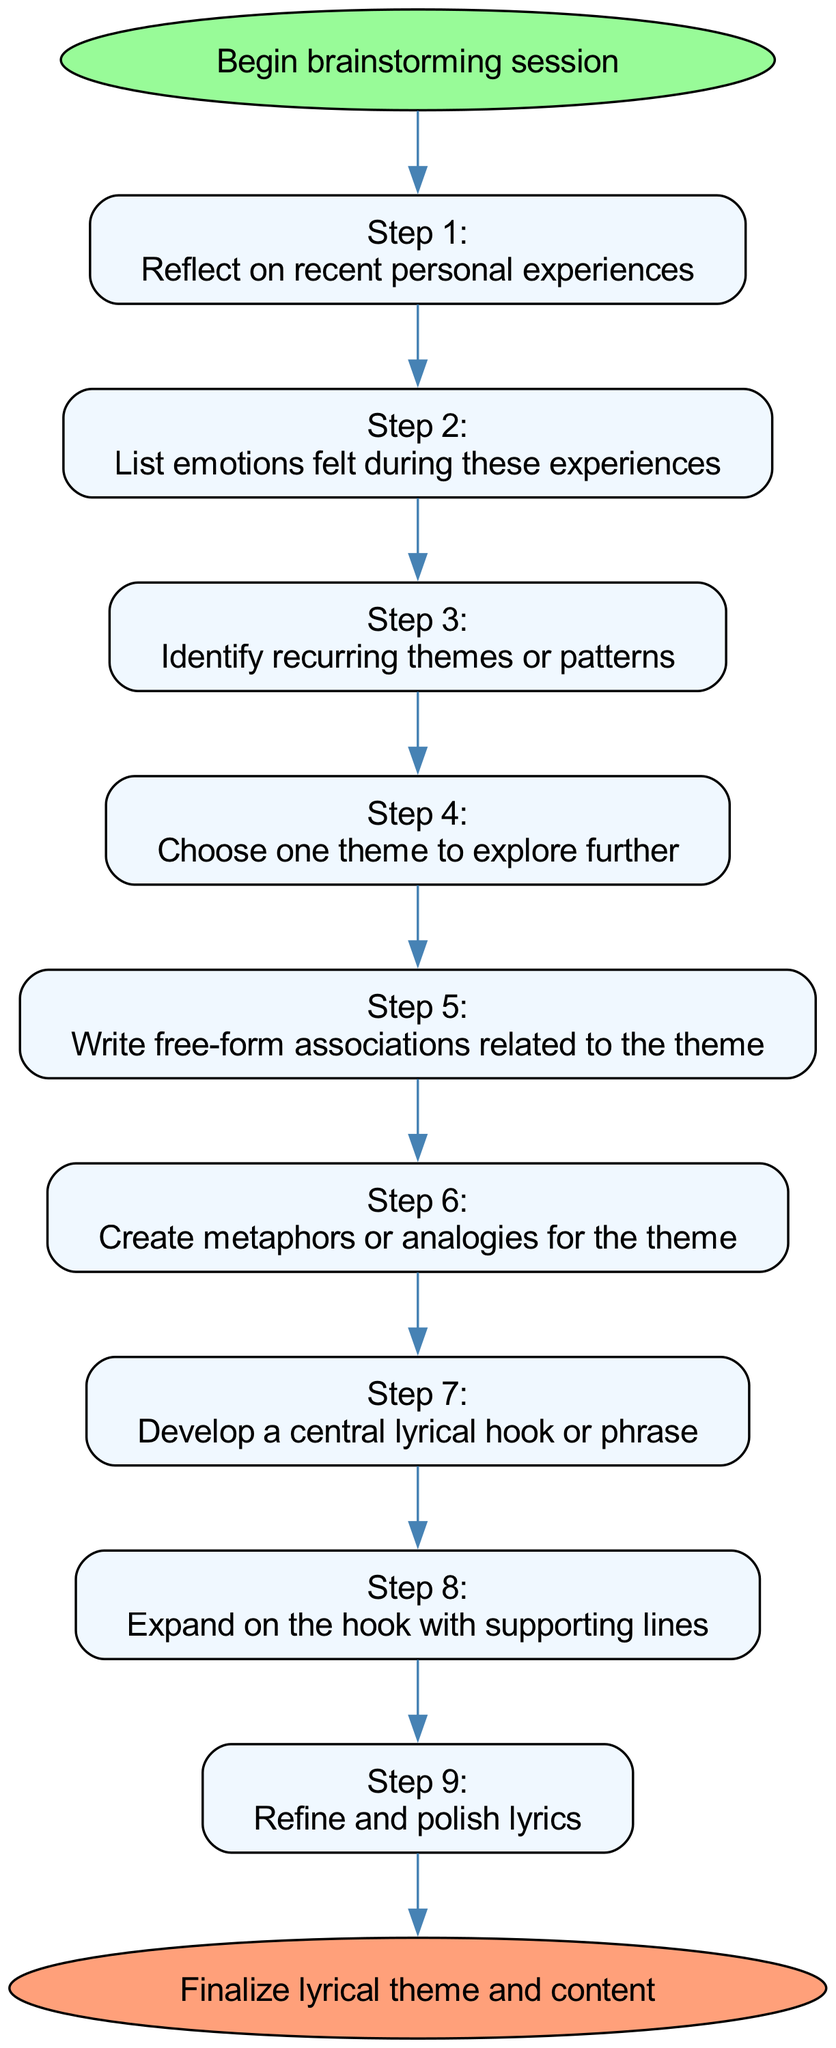What is the first step in the brainstorming session? The diagram starts with the "Begin brainstorming session" node. From there, the first step in the session is shown as "Reflect on recent personal experiences."
Answer: Reflect on recent personal experiences How many steps are there in the process? Counting the individual steps listed in the diagram, there are a total of 9 steps.
Answer: 9 What is the last step before finalizing the lyrical theme? The diagram indicates that the last step before reaching the end is "Refine and polish lyrics."
Answer: Refine and polish lyrics Which step focuses on emotions? The second step, which is "List emotions felt during these experiences," directly addresses the aspect of emotions as part of the brainstorming process.
Answer: List emotions felt during these experiences What precedes the step of writing free-form associations? According to the flow chart, the step that precedes "Write free-form associations related to the theme" is "Choose one theme to explore further."
Answer: Choose one theme to explore further Which steps involve creating content related to the chosen theme? Steps 5, 6, and 7 focus on creating content: "Write free-form associations related to the theme," "Create metaphors or analogies for the theme," and "Develop a central lyrical hook or phrase."
Answer: Write free-form associations, Create metaphors or analogies, Develop a central lyrical hook What is the purpose of the step involving metaphors or analogies? This step, "Create metaphors or analogies for the theme," aims to enhance the depth and creativity of the lyrical theme, allowing for richer expression.
Answer: Enhance lyrical depth How does “Identify recurring themes or patterns” relate to personal experiences? This step analyzes the emotions and situations from personal experiences to discover common threads that can be developed into lyrical content.
Answer: Discover common themes What is the next action after developing a central lyrical hook? Following the development of a central lyrical hook or phrase, the next action is to "Expand on the hook with supporting lines."
Answer: Expand on the hook with supporting lines 